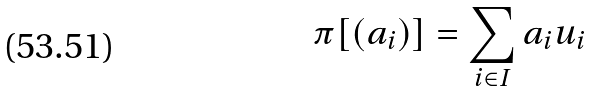Convert formula to latex. <formula><loc_0><loc_0><loc_500><loc_500>\pi [ ( a _ { i } ) ] = \sum _ { i \in I } a _ { i } u _ { i }</formula> 